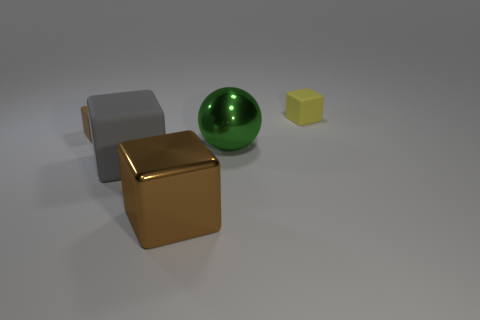Subtract all yellow cubes. How many cubes are left? 3 Subtract all brown blocks. How many blocks are left? 2 Subtract all blocks. How many objects are left? 1 Add 1 brown matte blocks. How many objects exist? 6 Subtract 1 balls. How many balls are left? 0 Add 5 blocks. How many blocks exist? 9 Subtract 0 red cylinders. How many objects are left? 5 Subtract all green blocks. Subtract all gray spheres. How many blocks are left? 4 Subtract all gray balls. How many gray blocks are left? 1 Subtract all small red cylinders. Subtract all gray blocks. How many objects are left? 4 